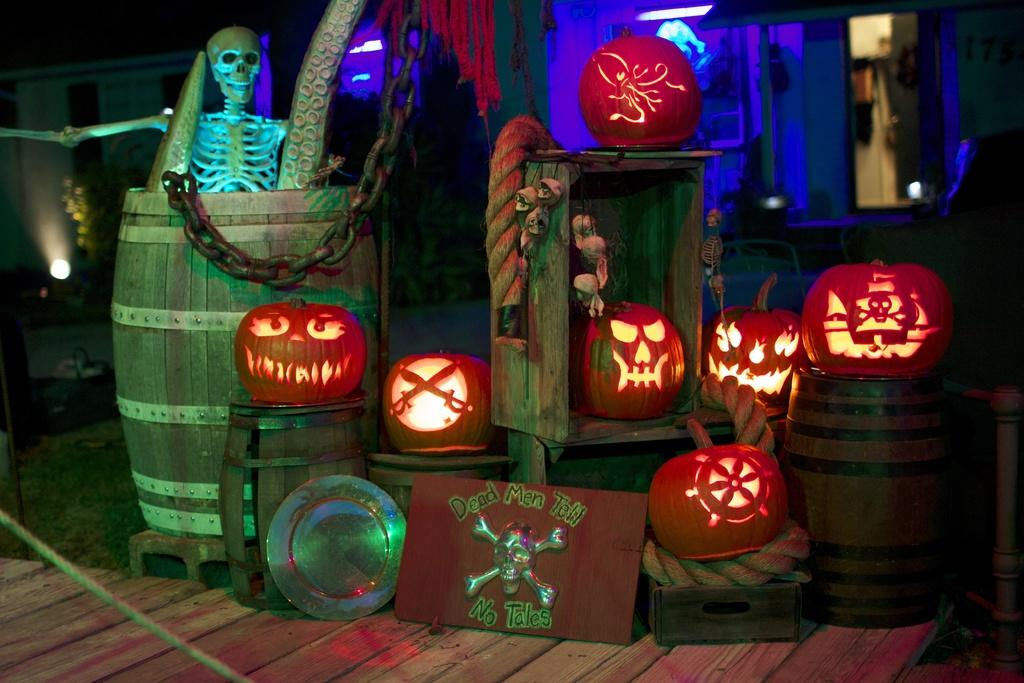What can be seen in the middle of the image? There are banners in the middle of the image. What type of decorations are present in the image? There are skulls and pumpkins in the image. What other objects can be seen in the image? There are some objects in the image. What can be seen in the background of the image? There are lights visible in the background of the image. What news is being reported by the cats in the image? There are no cats present in the image, so there is no news being reported. What type of cough is being depicted in the image? There is no cough depicted in the image; it features banners, skulls, pumpkins, and lights. 